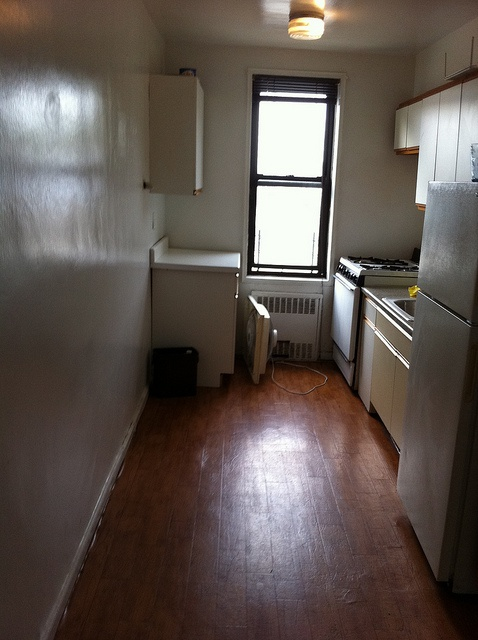Describe the objects in this image and their specific colors. I can see refrigerator in brown, black, and gray tones, oven in brown, white, black, gray, and darkgray tones, oven in brown, black, gray, and white tones, and sink in brown, black, gray, darkgray, and lightgray tones in this image. 